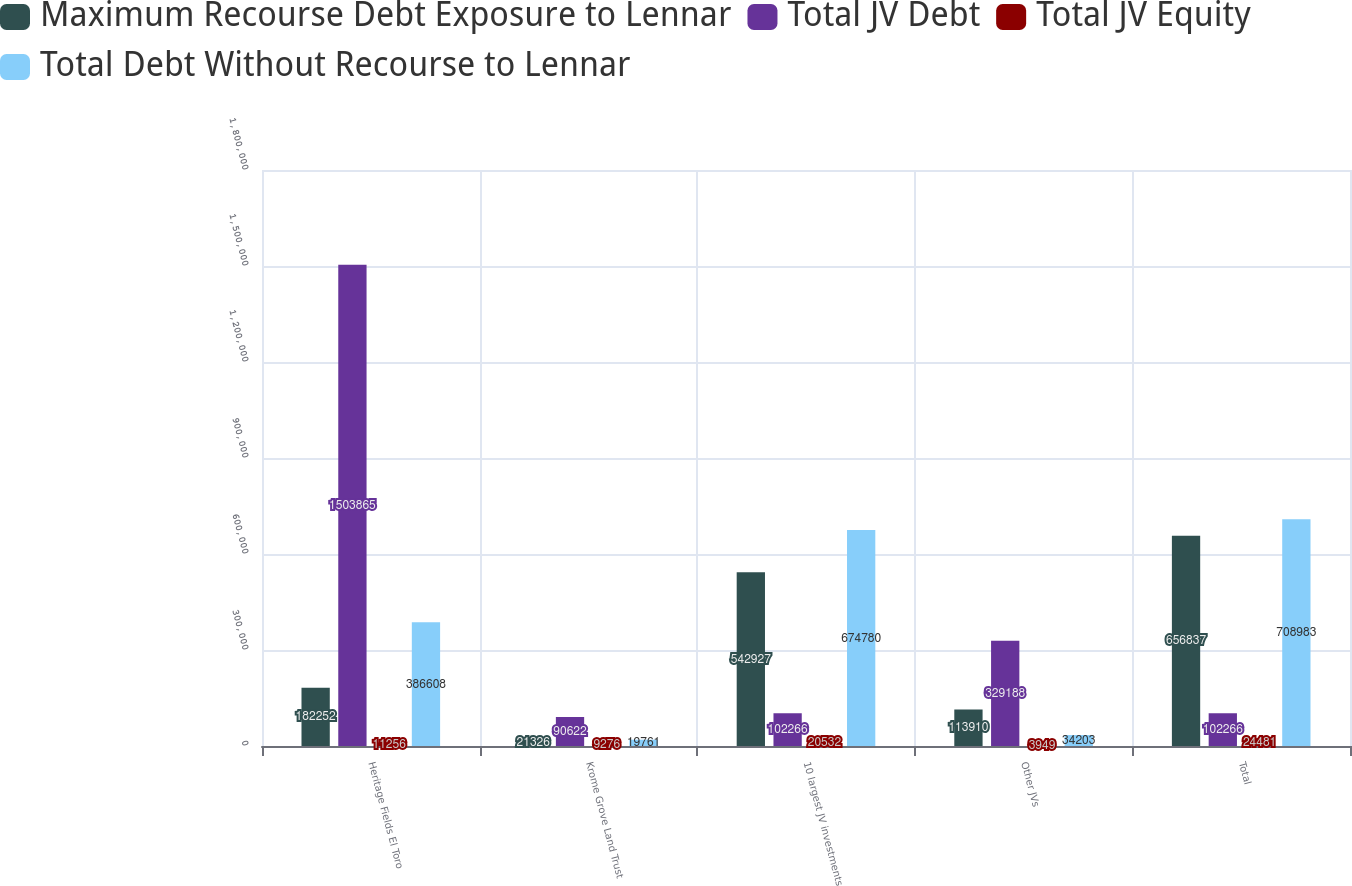Convert chart. <chart><loc_0><loc_0><loc_500><loc_500><stacked_bar_chart><ecel><fcel>Heritage Fields El Toro<fcel>Krome Grove Land Trust<fcel>10 largest JV investments<fcel>Other JVs<fcel>Total<nl><fcel>Maximum Recourse Debt Exposure to Lennar<fcel>182252<fcel>21326<fcel>542927<fcel>113910<fcel>656837<nl><fcel>Total JV Debt<fcel>1.50386e+06<fcel>90622<fcel>102266<fcel>329188<fcel>102266<nl><fcel>Total JV Equity<fcel>11256<fcel>9276<fcel>20532<fcel>3949<fcel>24481<nl><fcel>Total Debt Without Recourse to Lennar<fcel>386608<fcel>19761<fcel>674780<fcel>34203<fcel>708983<nl></chart> 